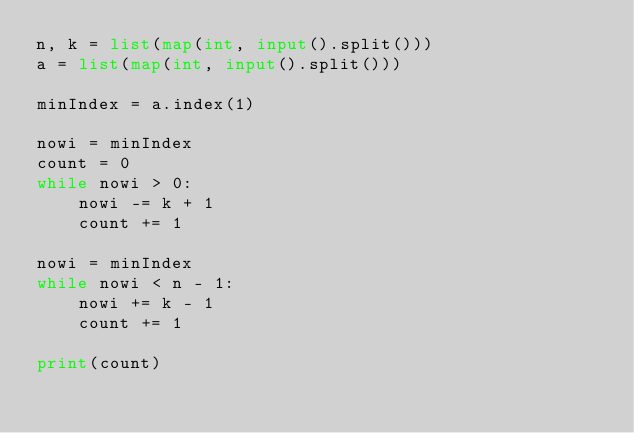Convert code to text. <code><loc_0><loc_0><loc_500><loc_500><_Python_>n, k = list(map(int, input().split()))
a = list(map(int, input().split()))

minIndex = a.index(1)

nowi = minIndex
count = 0
while nowi > 0:
    nowi -= k + 1
    count += 1

nowi = minIndex
while nowi < n - 1:
    nowi += k - 1
    count += 1

print(count)</code> 